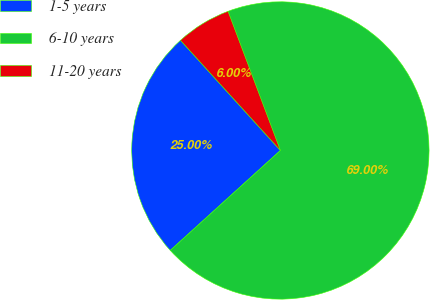Convert chart. <chart><loc_0><loc_0><loc_500><loc_500><pie_chart><fcel>1-5 years<fcel>6-10 years<fcel>11-20 years<nl><fcel>25.0%<fcel>69.0%<fcel>6.0%<nl></chart> 